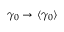<formula> <loc_0><loc_0><loc_500><loc_500>\gamma _ { 0 } \rightarrow \langle \gamma _ { 0 } \rangle</formula> 